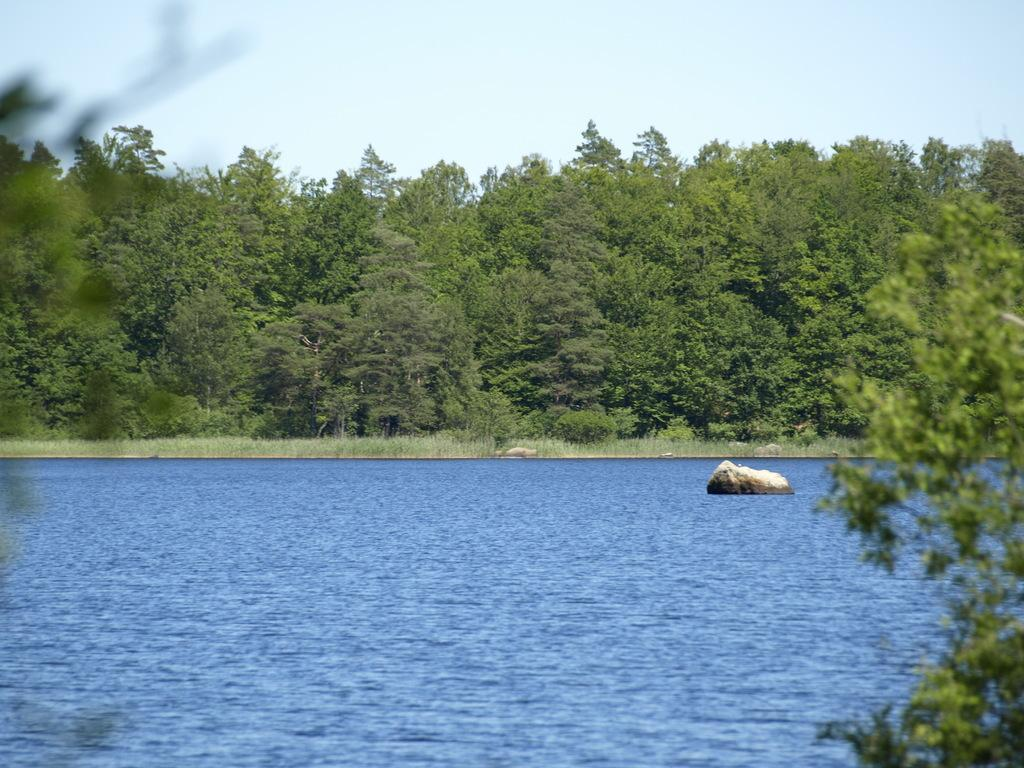What body of water is present in the image? There is a lake in the image. Is there any object in the lake? Yes, there is a rock in the lake. What type of vegetation can be seen around the lake? Trees are visible around the lake. What type of cake is being served for dinner in the image? There is no cake or dinner present in the image; it features a lake with a rock and trees around it. 